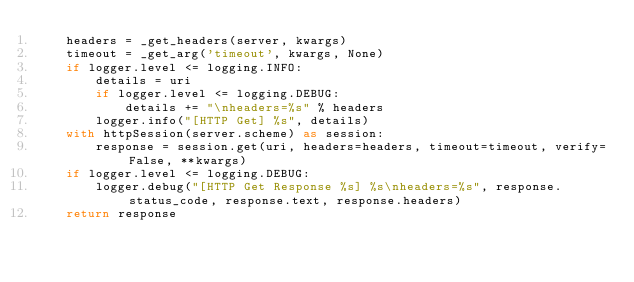Convert code to text. <code><loc_0><loc_0><loc_500><loc_500><_Python_>    headers = _get_headers(server, kwargs)
    timeout = _get_arg('timeout', kwargs, None)
    if logger.level <= logging.INFO:
        details = uri
        if logger.level <= logging.DEBUG:
            details += "\nheaders=%s" % headers
        logger.info("[HTTP Get] %s", details)
    with httpSession(server.scheme) as session:
        response = session.get(uri, headers=headers, timeout=timeout, verify=False, **kwargs)
    if logger.level <= logging.DEBUG:
        logger.debug("[HTTP Get Response %s] %s\nheaders=%s", response.status_code, response.text, response.headers)
    return response

</code> 